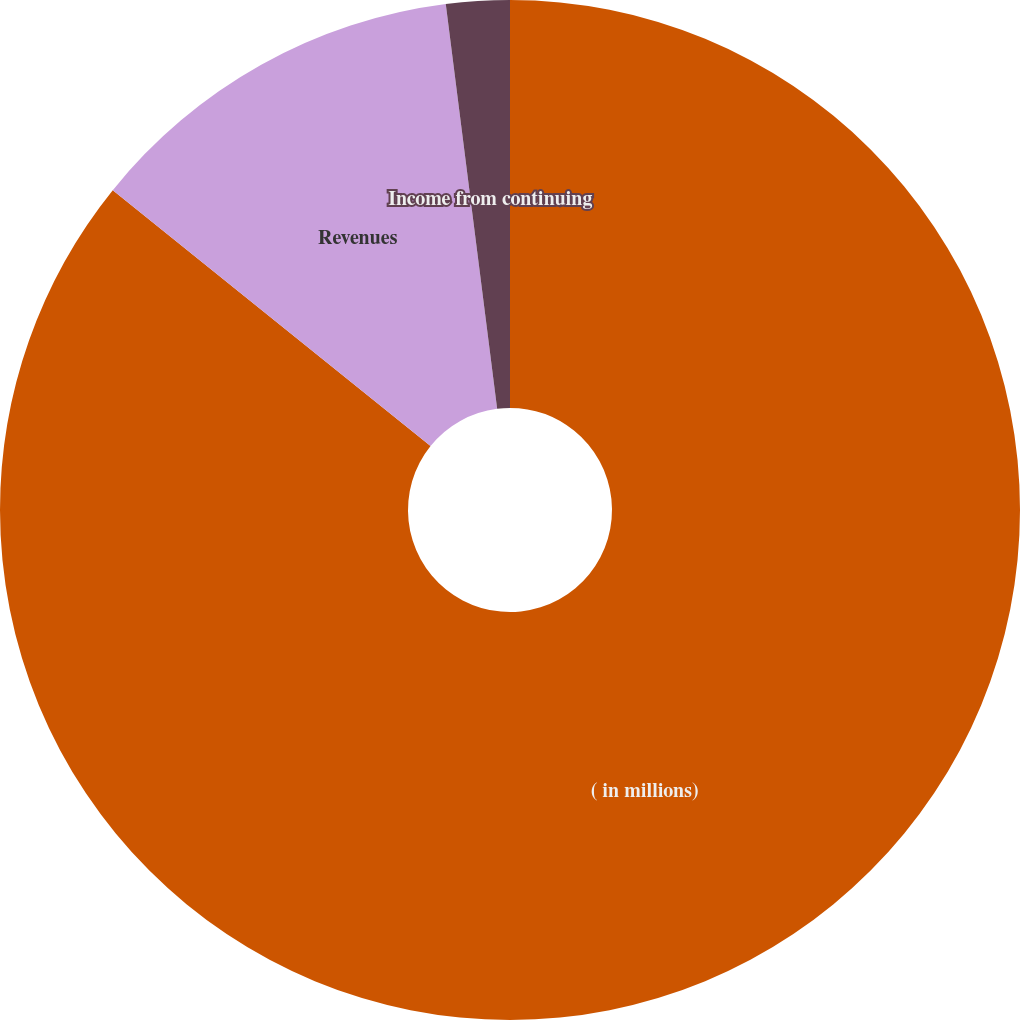<chart> <loc_0><loc_0><loc_500><loc_500><pie_chart><fcel>( in millions)<fcel>Revenues<fcel>Income from continuing<nl><fcel>85.79%<fcel>12.2%<fcel>2.01%<nl></chart> 